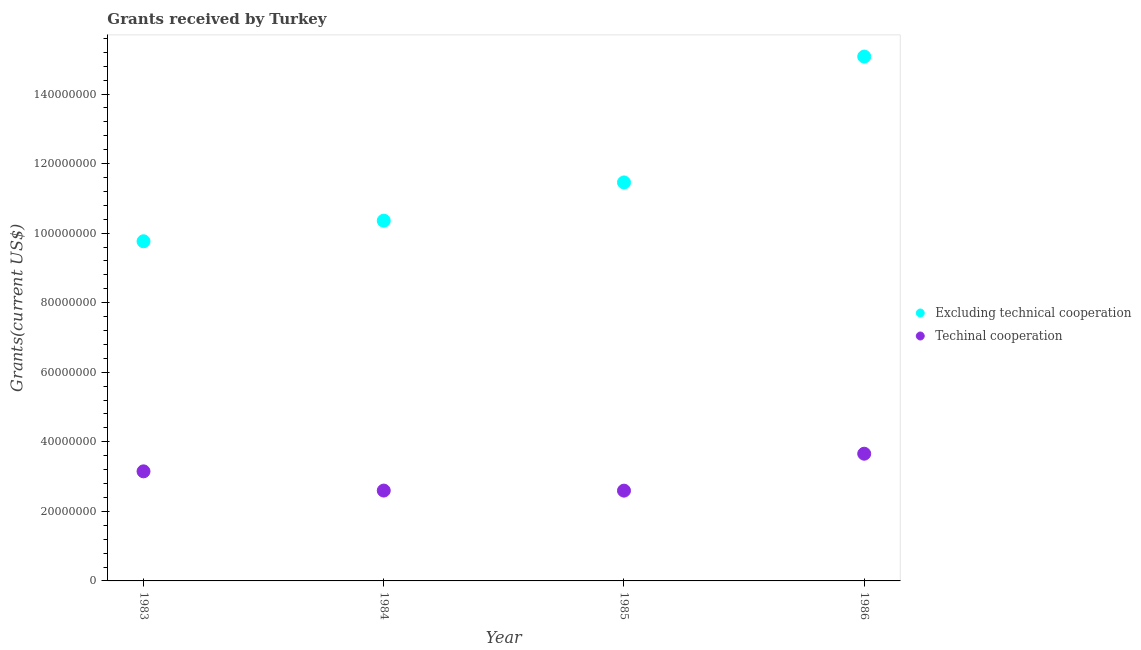How many different coloured dotlines are there?
Your answer should be very brief. 2. Is the number of dotlines equal to the number of legend labels?
Your answer should be very brief. Yes. What is the amount of grants received(including technical cooperation) in 1984?
Give a very brief answer. 2.60e+07. Across all years, what is the maximum amount of grants received(including technical cooperation)?
Your answer should be very brief. 3.66e+07. Across all years, what is the minimum amount of grants received(excluding technical cooperation)?
Offer a very short reply. 9.77e+07. In which year was the amount of grants received(excluding technical cooperation) maximum?
Ensure brevity in your answer.  1986. What is the total amount of grants received(excluding technical cooperation) in the graph?
Offer a very short reply. 4.67e+08. What is the difference between the amount of grants received(excluding technical cooperation) in 1984 and that in 1985?
Provide a succinct answer. -1.10e+07. What is the difference between the amount of grants received(including technical cooperation) in 1985 and the amount of grants received(excluding technical cooperation) in 1984?
Give a very brief answer. -7.76e+07. What is the average amount of grants received(including technical cooperation) per year?
Offer a very short reply. 3.00e+07. In the year 1985, what is the difference between the amount of grants received(including technical cooperation) and amount of grants received(excluding technical cooperation)?
Offer a very short reply. -8.86e+07. In how many years, is the amount of grants received(excluding technical cooperation) greater than 144000000 US$?
Give a very brief answer. 1. What is the ratio of the amount of grants received(excluding technical cooperation) in 1984 to that in 1985?
Provide a short and direct response. 0.9. What is the difference between the highest and the second highest amount of grants received(including technical cooperation)?
Offer a terse response. 5.07e+06. What is the difference between the highest and the lowest amount of grants received(excluding technical cooperation)?
Give a very brief answer. 5.31e+07. In how many years, is the amount of grants received(excluding technical cooperation) greater than the average amount of grants received(excluding technical cooperation) taken over all years?
Give a very brief answer. 1. Is the sum of the amount of grants received(including technical cooperation) in 1983 and 1985 greater than the maximum amount of grants received(excluding technical cooperation) across all years?
Your answer should be compact. No. Is the amount of grants received(excluding technical cooperation) strictly greater than the amount of grants received(including technical cooperation) over the years?
Keep it short and to the point. Yes. How many years are there in the graph?
Keep it short and to the point. 4. Are the values on the major ticks of Y-axis written in scientific E-notation?
Keep it short and to the point. No. Does the graph contain grids?
Offer a terse response. No. Where does the legend appear in the graph?
Provide a succinct answer. Center right. How are the legend labels stacked?
Provide a succinct answer. Vertical. What is the title of the graph?
Your answer should be compact. Grants received by Turkey. What is the label or title of the X-axis?
Your answer should be compact. Year. What is the label or title of the Y-axis?
Offer a terse response. Grants(current US$). What is the Grants(current US$) of Excluding technical cooperation in 1983?
Your answer should be very brief. 9.77e+07. What is the Grants(current US$) of Techinal cooperation in 1983?
Your response must be concise. 3.15e+07. What is the Grants(current US$) of Excluding technical cooperation in 1984?
Ensure brevity in your answer.  1.04e+08. What is the Grants(current US$) of Techinal cooperation in 1984?
Your answer should be compact. 2.60e+07. What is the Grants(current US$) of Excluding technical cooperation in 1985?
Make the answer very short. 1.15e+08. What is the Grants(current US$) of Techinal cooperation in 1985?
Ensure brevity in your answer.  2.60e+07. What is the Grants(current US$) in Excluding technical cooperation in 1986?
Offer a terse response. 1.51e+08. What is the Grants(current US$) in Techinal cooperation in 1986?
Give a very brief answer. 3.66e+07. Across all years, what is the maximum Grants(current US$) of Excluding technical cooperation?
Offer a very short reply. 1.51e+08. Across all years, what is the maximum Grants(current US$) in Techinal cooperation?
Offer a terse response. 3.66e+07. Across all years, what is the minimum Grants(current US$) in Excluding technical cooperation?
Provide a succinct answer. 9.77e+07. Across all years, what is the minimum Grants(current US$) of Techinal cooperation?
Make the answer very short. 2.60e+07. What is the total Grants(current US$) in Excluding technical cooperation in the graph?
Ensure brevity in your answer.  4.67e+08. What is the total Grants(current US$) of Techinal cooperation in the graph?
Offer a very short reply. 1.20e+08. What is the difference between the Grants(current US$) of Excluding technical cooperation in 1983 and that in 1984?
Ensure brevity in your answer.  -5.92e+06. What is the difference between the Grants(current US$) in Techinal cooperation in 1983 and that in 1984?
Provide a short and direct response. 5.53e+06. What is the difference between the Grants(current US$) of Excluding technical cooperation in 1983 and that in 1985?
Your response must be concise. -1.69e+07. What is the difference between the Grants(current US$) in Techinal cooperation in 1983 and that in 1985?
Make the answer very short. 5.55e+06. What is the difference between the Grants(current US$) of Excluding technical cooperation in 1983 and that in 1986?
Offer a terse response. -5.31e+07. What is the difference between the Grants(current US$) in Techinal cooperation in 1983 and that in 1986?
Provide a succinct answer. -5.07e+06. What is the difference between the Grants(current US$) of Excluding technical cooperation in 1984 and that in 1985?
Make the answer very short. -1.10e+07. What is the difference between the Grants(current US$) in Techinal cooperation in 1984 and that in 1985?
Provide a short and direct response. 2.00e+04. What is the difference between the Grants(current US$) of Excluding technical cooperation in 1984 and that in 1986?
Give a very brief answer. -4.72e+07. What is the difference between the Grants(current US$) of Techinal cooperation in 1984 and that in 1986?
Provide a succinct answer. -1.06e+07. What is the difference between the Grants(current US$) of Excluding technical cooperation in 1985 and that in 1986?
Give a very brief answer. -3.62e+07. What is the difference between the Grants(current US$) in Techinal cooperation in 1985 and that in 1986?
Your answer should be compact. -1.06e+07. What is the difference between the Grants(current US$) in Excluding technical cooperation in 1983 and the Grants(current US$) in Techinal cooperation in 1984?
Give a very brief answer. 7.17e+07. What is the difference between the Grants(current US$) in Excluding technical cooperation in 1983 and the Grants(current US$) in Techinal cooperation in 1985?
Make the answer very short. 7.17e+07. What is the difference between the Grants(current US$) in Excluding technical cooperation in 1983 and the Grants(current US$) in Techinal cooperation in 1986?
Your answer should be very brief. 6.11e+07. What is the difference between the Grants(current US$) in Excluding technical cooperation in 1984 and the Grants(current US$) in Techinal cooperation in 1985?
Your response must be concise. 7.76e+07. What is the difference between the Grants(current US$) of Excluding technical cooperation in 1984 and the Grants(current US$) of Techinal cooperation in 1986?
Keep it short and to the point. 6.70e+07. What is the difference between the Grants(current US$) in Excluding technical cooperation in 1985 and the Grants(current US$) in Techinal cooperation in 1986?
Keep it short and to the point. 7.80e+07. What is the average Grants(current US$) of Excluding technical cooperation per year?
Your answer should be compact. 1.17e+08. What is the average Grants(current US$) of Techinal cooperation per year?
Ensure brevity in your answer.  3.00e+07. In the year 1983, what is the difference between the Grants(current US$) in Excluding technical cooperation and Grants(current US$) in Techinal cooperation?
Your answer should be compact. 6.62e+07. In the year 1984, what is the difference between the Grants(current US$) in Excluding technical cooperation and Grants(current US$) in Techinal cooperation?
Keep it short and to the point. 7.76e+07. In the year 1985, what is the difference between the Grants(current US$) of Excluding technical cooperation and Grants(current US$) of Techinal cooperation?
Offer a terse response. 8.86e+07. In the year 1986, what is the difference between the Grants(current US$) in Excluding technical cooperation and Grants(current US$) in Techinal cooperation?
Ensure brevity in your answer.  1.14e+08. What is the ratio of the Grants(current US$) in Excluding technical cooperation in 1983 to that in 1984?
Keep it short and to the point. 0.94. What is the ratio of the Grants(current US$) of Techinal cooperation in 1983 to that in 1984?
Offer a terse response. 1.21. What is the ratio of the Grants(current US$) of Excluding technical cooperation in 1983 to that in 1985?
Give a very brief answer. 0.85. What is the ratio of the Grants(current US$) of Techinal cooperation in 1983 to that in 1985?
Your response must be concise. 1.21. What is the ratio of the Grants(current US$) in Excluding technical cooperation in 1983 to that in 1986?
Provide a short and direct response. 0.65. What is the ratio of the Grants(current US$) in Techinal cooperation in 1983 to that in 1986?
Your response must be concise. 0.86. What is the ratio of the Grants(current US$) of Excluding technical cooperation in 1984 to that in 1985?
Provide a succinct answer. 0.9. What is the ratio of the Grants(current US$) in Techinal cooperation in 1984 to that in 1985?
Provide a short and direct response. 1. What is the ratio of the Grants(current US$) in Excluding technical cooperation in 1984 to that in 1986?
Your answer should be very brief. 0.69. What is the ratio of the Grants(current US$) in Techinal cooperation in 1984 to that in 1986?
Give a very brief answer. 0.71. What is the ratio of the Grants(current US$) in Excluding technical cooperation in 1985 to that in 1986?
Ensure brevity in your answer.  0.76. What is the ratio of the Grants(current US$) of Techinal cooperation in 1985 to that in 1986?
Offer a very short reply. 0.71. What is the difference between the highest and the second highest Grants(current US$) in Excluding technical cooperation?
Your answer should be very brief. 3.62e+07. What is the difference between the highest and the second highest Grants(current US$) of Techinal cooperation?
Your response must be concise. 5.07e+06. What is the difference between the highest and the lowest Grants(current US$) in Excluding technical cooperation?
Your response must be concise. 5.31e+07. What is the difference between the highest and the lowest Grants(current US$) in Techinal cooperation?
Your answer should be very brief. 1.06e+07. 